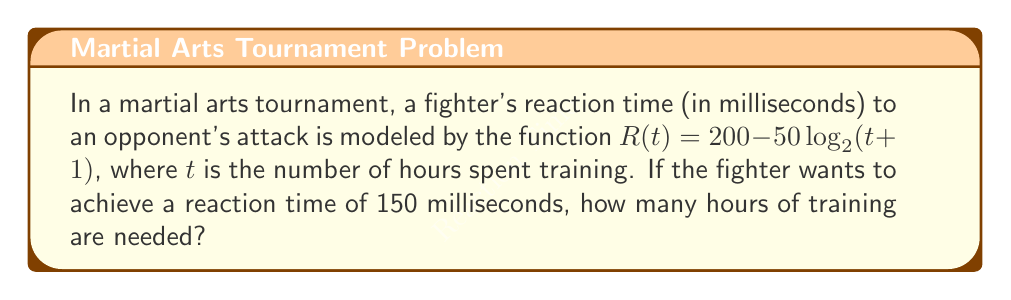Teach me how to tackle this problem. Let's approach this step-by-step:

1) We want to find $t$ when $R(t) = 150$. So, we can set up the equation:

   $150 = 200 - 50\log_2(t+1)$

2) Subtract 200 from both sides:

   $-50 = -50\log_2(t+1)$

3) Divide both sides by -50:

   $1 = \log_2(t+1)$

4) Now, we need to solve for $t$. We can do this by applying $2^x$ to both sides:

   $2^1 = 2^{\log_2(t+1)}$

5) Simplify:

   $2 = t+1$

6) Subtract 1 from both sides:

   $1 = t$

Therefore, the fighter needs 1 hour of training to achieve a reaction time of 150 milliseconds.
Answer: 1 hour 